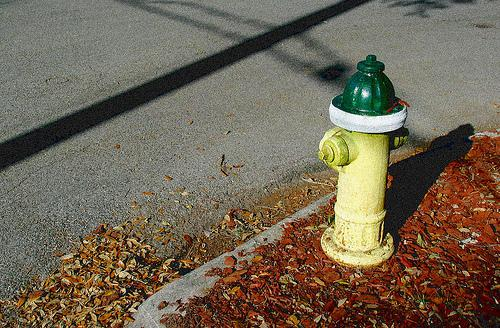Question: what color is the bottom of the fire hydrant?
Choices:
A. Red.
B. Blue.
C. White.
D. Yellow.
Answer with the letter. Answer: D Question: what color is the pavement?
Choices:
A. Black.
B. Brown.
C. Grey.
D. Blue.
Answer with the letter. Answer: C 